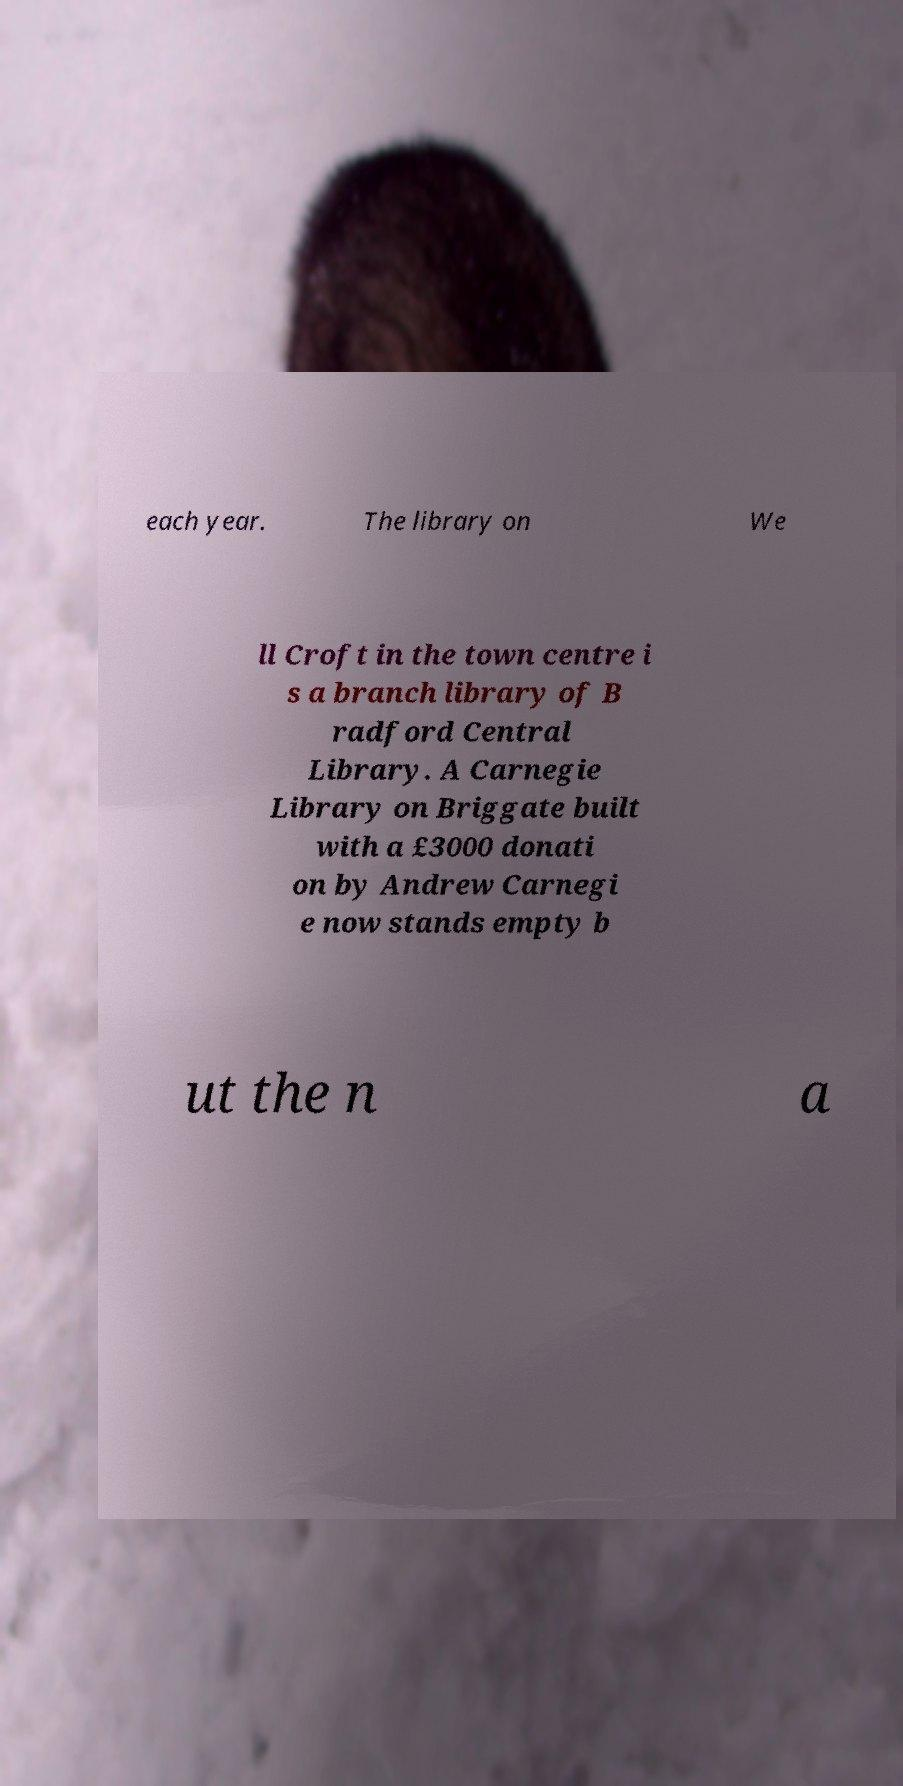Could you extract and type out the text from this image? each year. The library on We ll Croft in the town centre i s a branch library of B radford Central Library. A Carnegie Library on Briggate built with a £3000 donati on by Andrew Carnegi e now stands empty b ut the n a 